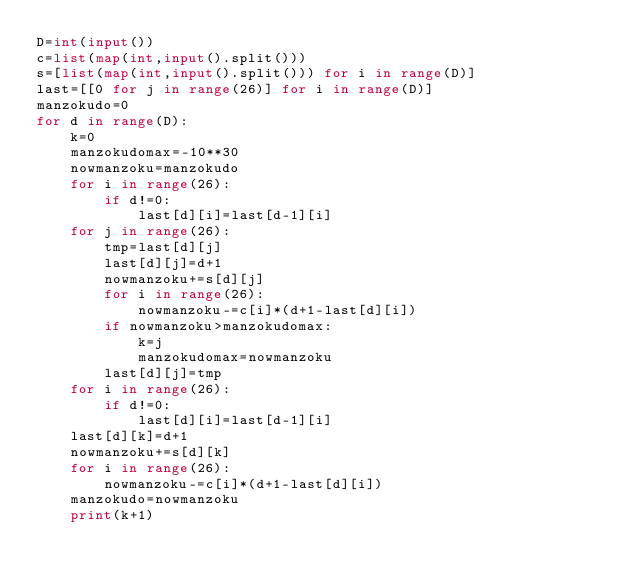<code> <loc_0><loc_0><loc_500><loc_500><_Python_>D=int(input())
c=list(map(int,input().split()))
s=[list(map(int,input().split())) for i in range(D)]
last=[[0 for j in range(26)] for i in range(D)]
manzokudo=0
for d in range(D):
    k=0
    manzokudomax=-10**30
    nowmanzoku=manzokudo
    for i in range(26):
        if d!=0:
            last[d][i]=last[d-1][i]
    for j in range(26):
        tmp=last[d][j]
        last[d][j]=d+1
        nowmanzoku+=s[d][j]
        for i in range(26):
            nowmanzoku-=c[i]*(d+1-last[d][i])
        if nowmanzoku>manzokudomax:
            k=j
            manzokudomax=nowmanzoku
        last[d][j]=tmp
    for i in range(26):
        if d!=0:
            last[d][i]=last[d-1][i]
    last[d][k]=d+1
    nowmanzoku+=s[d][k]
    for i in range(26):
        nowmanzoku-=c[i]*(d+1-last[d][i])
    manzokudo=nowmanzoku
    print(k+1)
</code> 